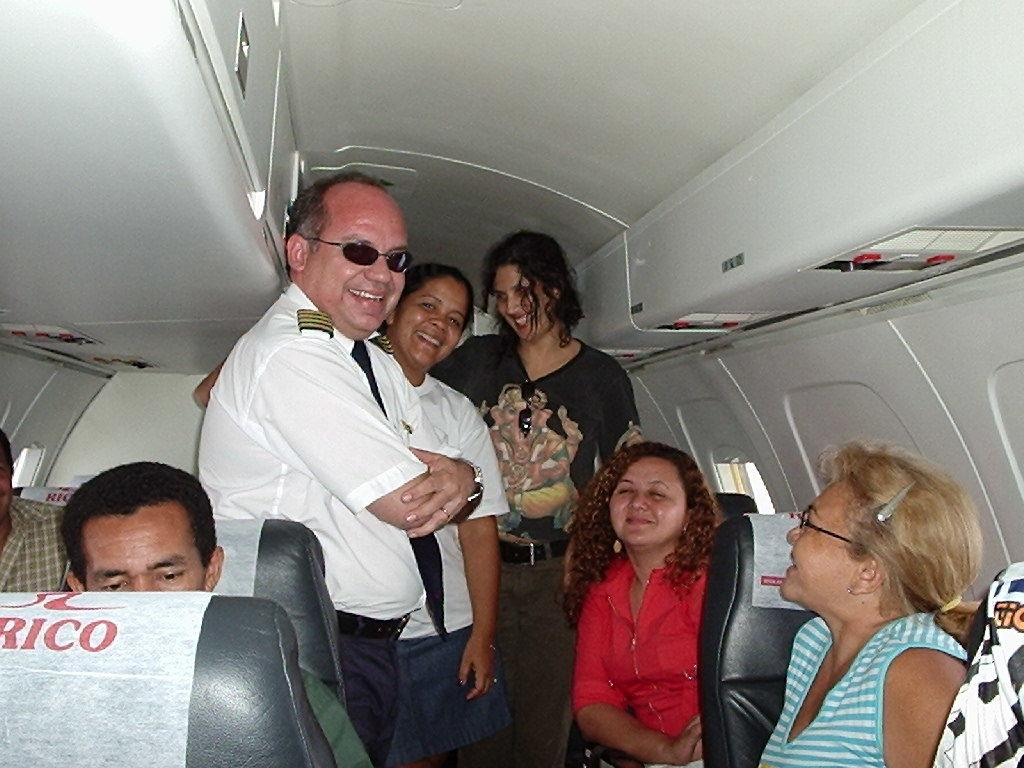How many people are in the image? There is a group of people in the image. What are some of the people doing in the image? Some people are sitting, and some people are standing. Where are the people located in the image? The people are in a plane. What type of stocking is visible on the animal in the image? There is no animal or stocking present in the image; it features a group of people in a plane. 